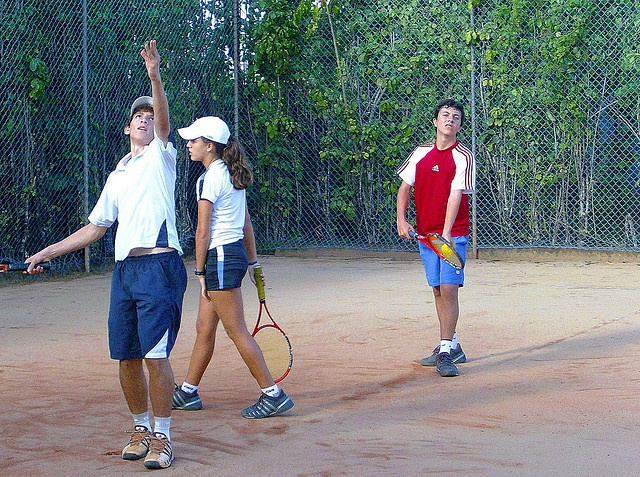Describe the objects in this image and their specific colors. I can see people in black, white, navy, gray, and darkgray tones, people in black, white, gray, and navy tones, people in black, brown, white, gray, and lightpink tones, tennis racket in black and tan tones, and tennis racket in black, darkgray, olive, red, and gray tones in this image. 